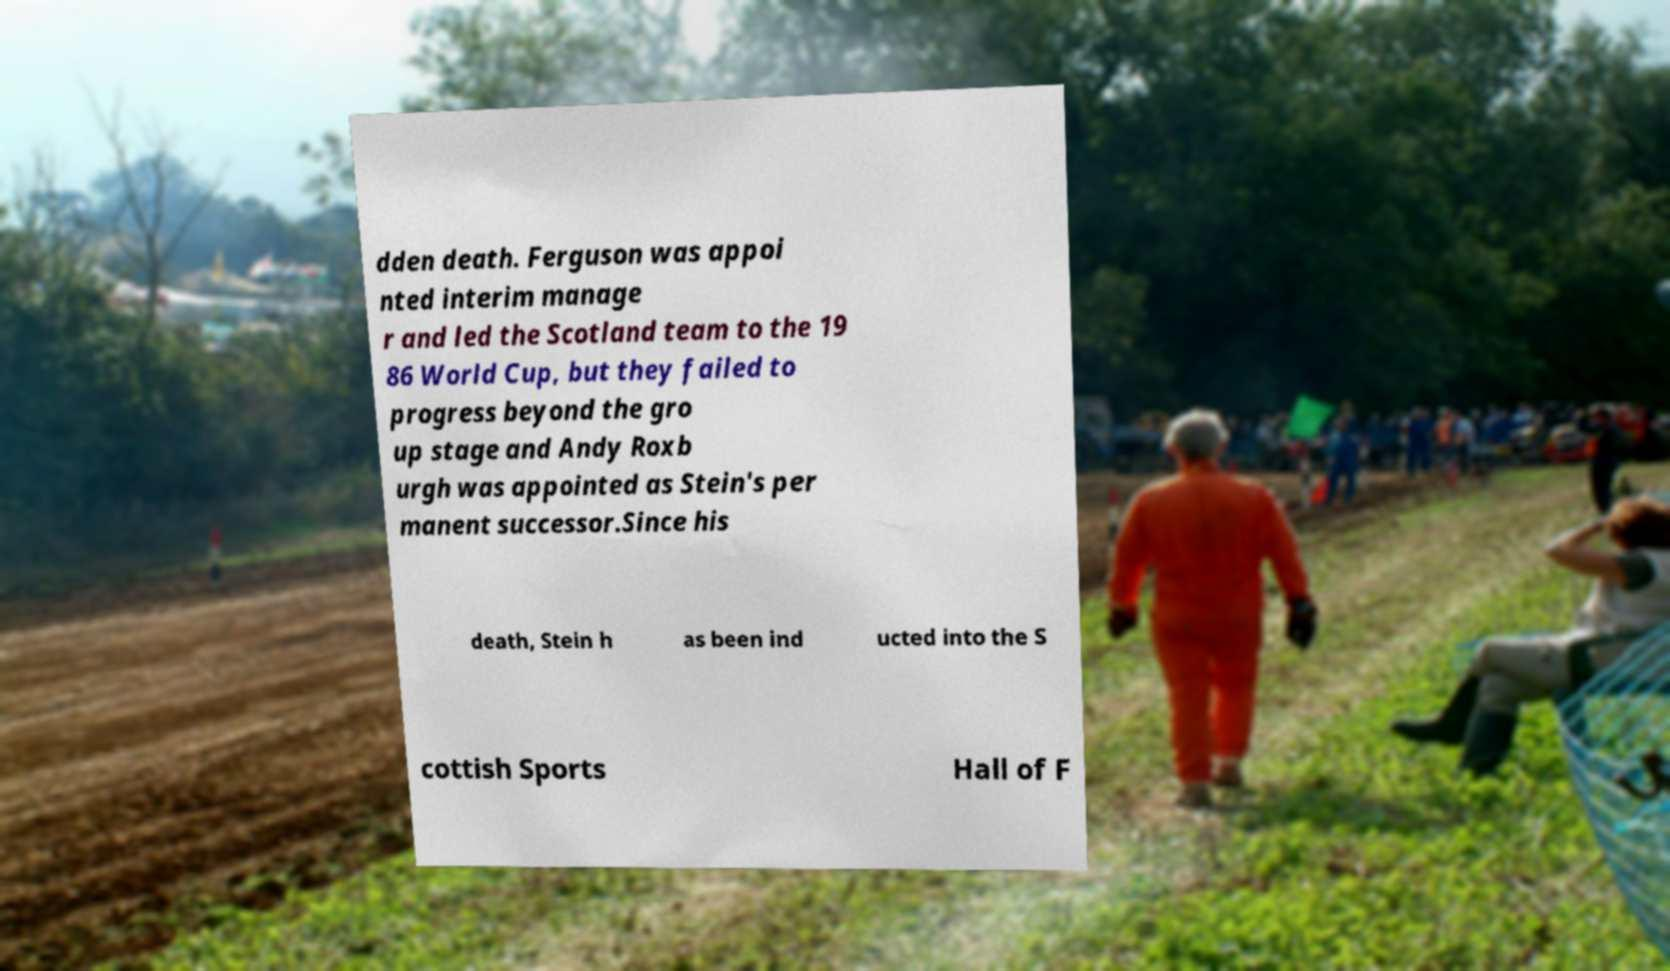Please identify and transcribe the text found in this image. dden death. Ferguson was appoi nted interim manage r and led the Scotland team to the 19 86 World Cup, but they failed to progress beyond the gro up stage and Andy Roxb urgh was appointed as Stein's per manent successor.Since his death, Stein h as been ind ucted into the S cottish Sports Hall of F 